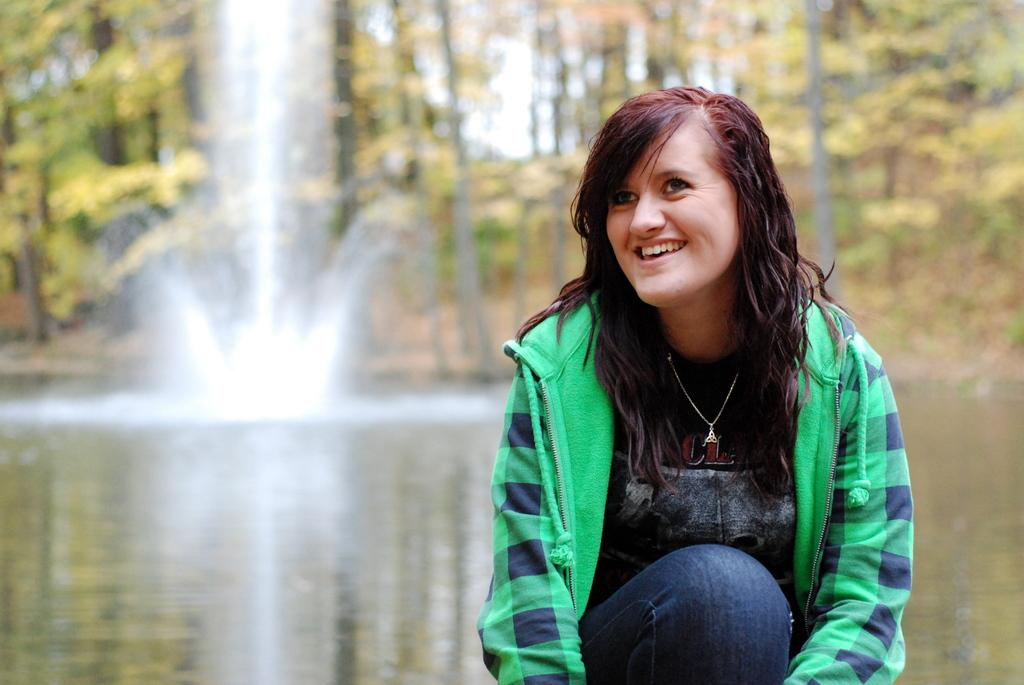Who is the main subject in the image? There is a girl in the image. What is the girl wearing? The girl is wearing a green jacket. What position is the girl in? The girl is in a squatting position. What can be seen in the background of the image? There is water, trees, and a waterfall visible in the background of the image. Where are the scissors placed in the image? There are no scissors present in the image. What type of building can be seen in the background of the image? There is no building visible in the background of the image; it features water, trees, and a waterfall. 